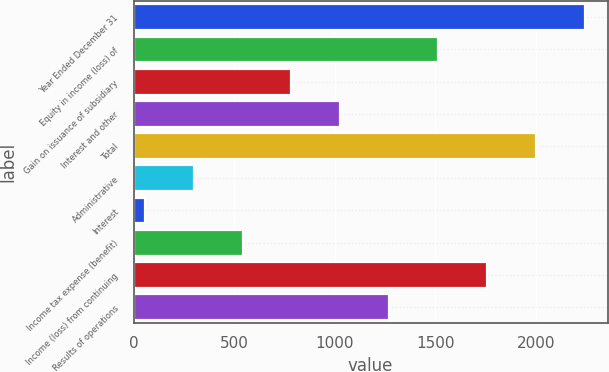Convert chart. <chart><loc_0><loc_0><loc_500><loc_500><bar_chart><fcel>Year Ended December 31<fcel>Equity in income (loss) of<fcel>Gain on issuance of subsidiary<fcel>Interest and other<fcel>Total<fcel>Administrative<fcel>Interest<fcel>Income tax expense (benefit)<fcel>Income (loss) from continuing<fcel>Results of operations<nl><fcel>2245.6<fcel>1515.4<fcel>785.2<fcel>1028.6<fcel>2002.2<fcel>298.4<fcel>55<fcel>541.8<fcel>1758.8<fcel>1272<nl></chart> 